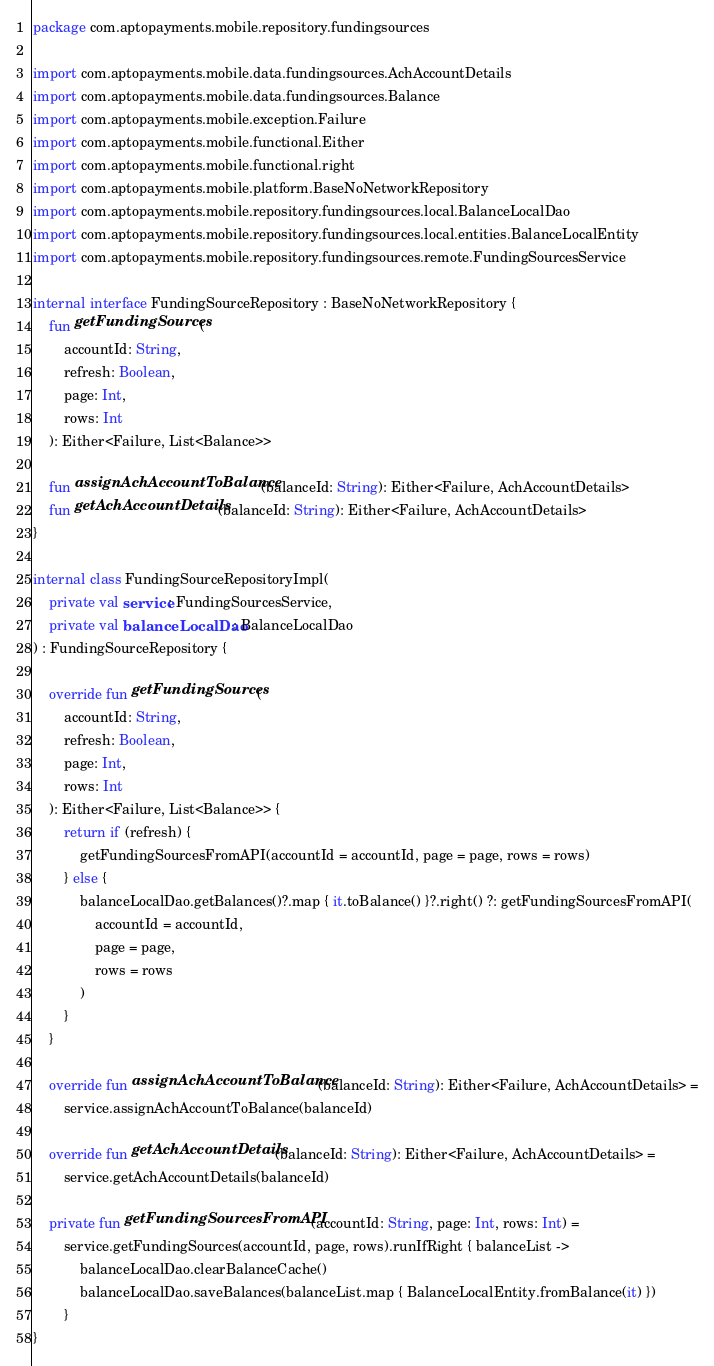<code> <loc_0><loc_0><loc_500><loc_500><_Kotlin_>package com.aptopayments.mobile.repository.fundingsources

import com.aptopayments.mobile.data.fundingsources.AchAccountDetails
import com.aptopayments.mobile.data.fundingsources.Balance
import com.aptopayments.mobile.exception.Failure
import com.aptopayments.mobile.functional.Either
import com.aptopayments.mobile.functional.right
import com.aptopayments.mobile.platform.BaseNoNetworkRepository
import com.aptopayments.mobile.repository.fundingsources.local.BalanceLocalDao
import com.aptopayments.mobile.repository.fundingsources.local.entities.BalanceLocalEntity
import com.aptopayments.mobile.repository.fundingsources.remote.FundingSourcesService

internal interface FundingSourceRepository : BaseNoNetworkRepository {
    fun getFundingSources(
        accountId: String,
        refresh: Boolean,
        page: Int,
        rows: Int
    ): Either<Failure, List<Balance>>

    fun assignAchAccountToBalance(balanceId: String): Either<Failure, AchAccountDetails>
    fun getAchAccountDetails(balanceId: String): Either<Failure, AchAccountDetails>
}

internal class FundingSourceRepositoryImpl(
    private val service: FundingSourcesService,
    private val balanceLocalDao: BalanceLocalDao
) : FundingSourceRepository {

    override fun getFundingSources(
        accountId: String,
        refresh: Boolean,
        page: Int,
        rows: Int
    ): Either<Failure, List<Balance>> {
        return if (refresh) {
            getFundingSourcesFromAPI(accountId = accountId, page = page, rows = rows)
        } else {
            balanceLocalDao.getBalances()?.map { it.toBalance() }?.right() ?: getFundingSourcesFromAPI(
                accountId = accountId,
                page = page,
                rows = rows
            )
        }
    }

    override fun assignAchAccountToBalance(balanceId: String): Either<Failure, AchAccountDetails> =
        service.assignAchAccountToBalance(balanceId)

    override fun getAchAccountDetails(balanceId: String): Either<Failure, AchAccountDetails> =
        service.getAchAccountDetails(balanceId)

    private fun getFundingSourcesFromAPI(accountId: String, page: Int, rows: Int) =
        service.getFundingSources(accountId, page, rows).runIfRight { balanceList ->
            balanceLocalDao.clearBalanceCache()
            balanceLocalDao.saveBalances(balanceList.map { BalanceLocalEntity.fromBalance(it) })
        }
}
</code> 